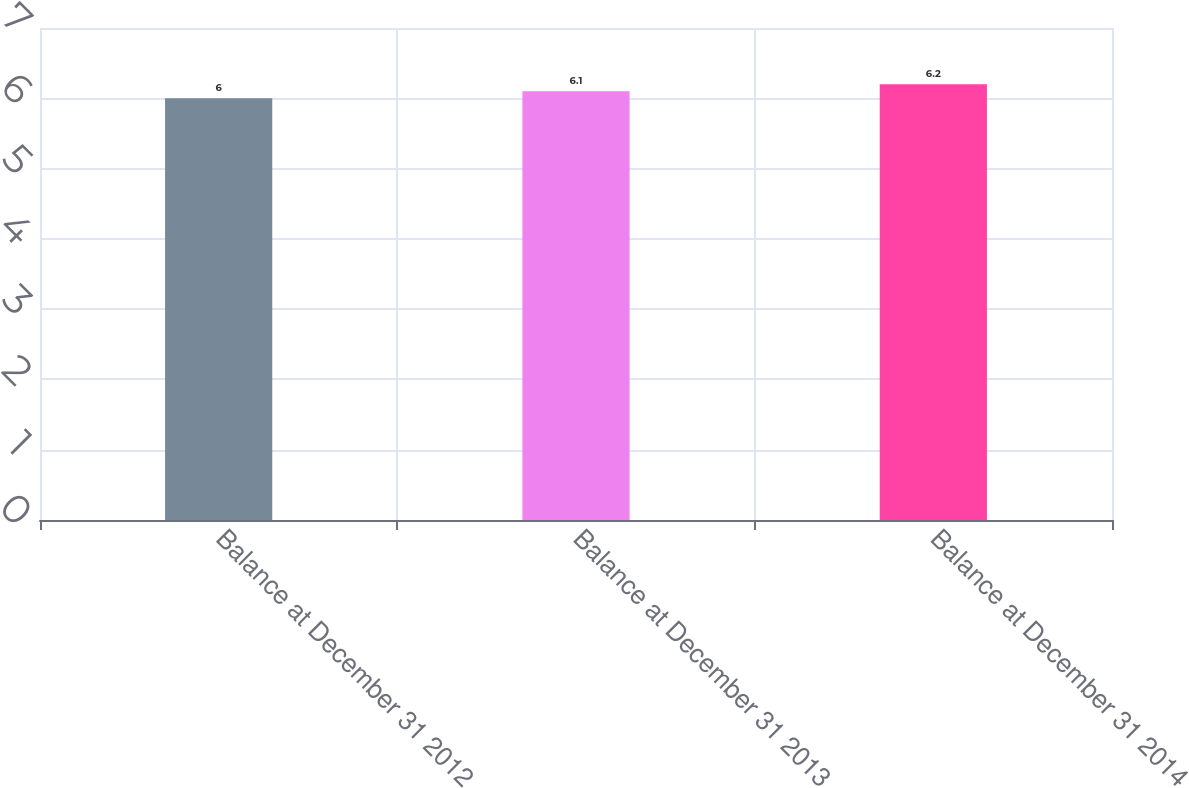Convert chart. <chart><loc_0><loc_0><loc_500><loc_500><bar_chart><fcel>Balance at December 31 2012<fcel>Balance at December 31 2013<fcel>Balance at December 31 2014<nl><fcel>6<fcel>6.1<fcel>6.2<nl></chart> 